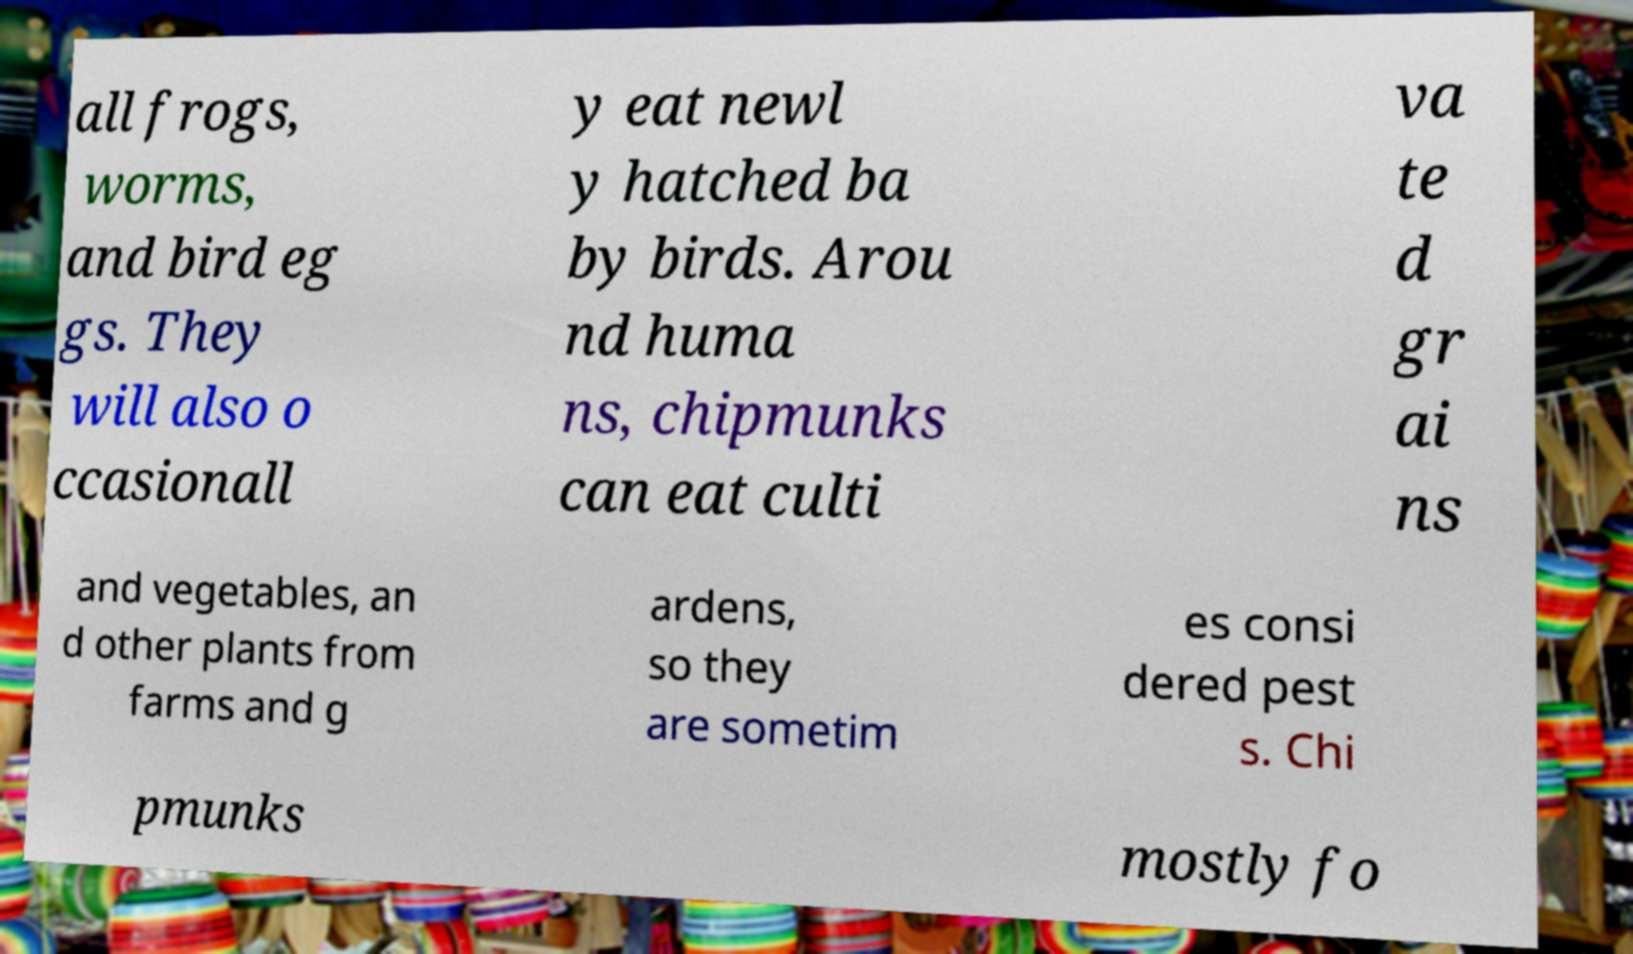For documentation purposes, I need the text within this image transcribed. Could you provide that? all frogs, worms, and bird eg gs. They will also o ccasionall y eat newl y hatched ba by birds. Arou nd huma ns, chipmunks can eat culti va te d gr ai ns and vegetables, an d other plants from farms and g ardens, so they are sometim es consi dered pest s. Chi pmunks mostly fo 